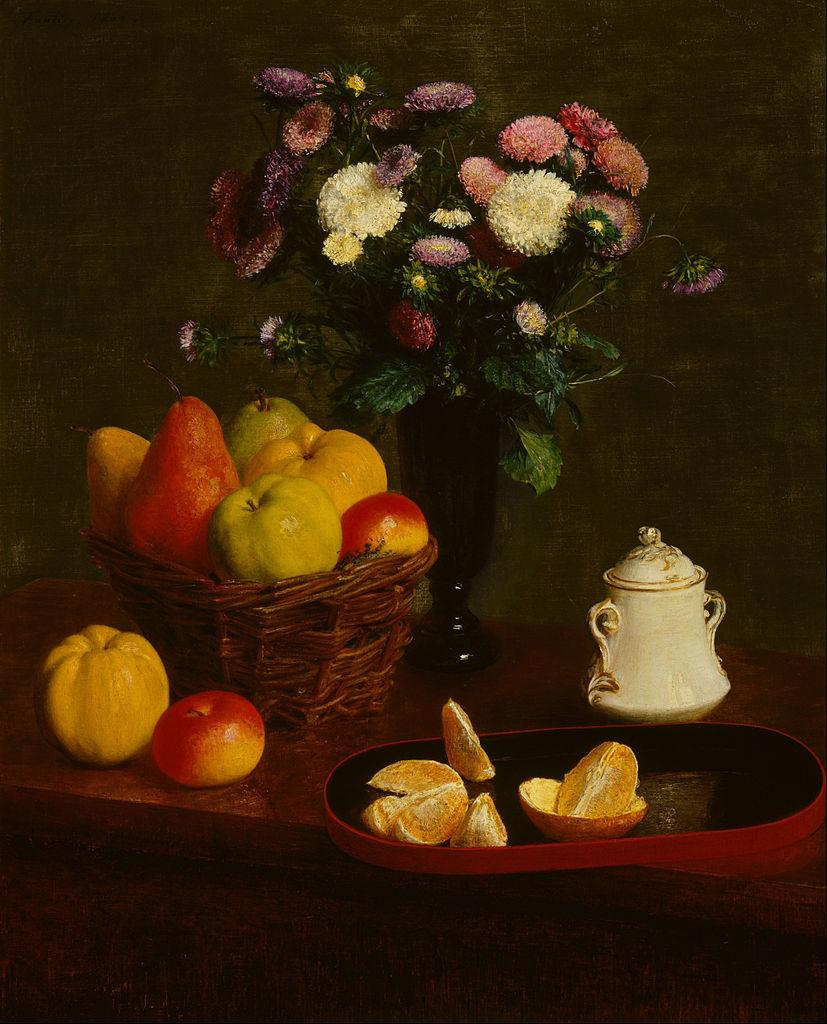What is the main subject of the image? There is a painting in the image. What other objects can be seen in the image? There is a basket with fruits, a jug, a vase with a flower bouquet, and a plate with orange pieces in the image. What type of mark can be seen on the copper jug in the image? There is no copper jug present in the image, and therefore no mark can be seen on it. 